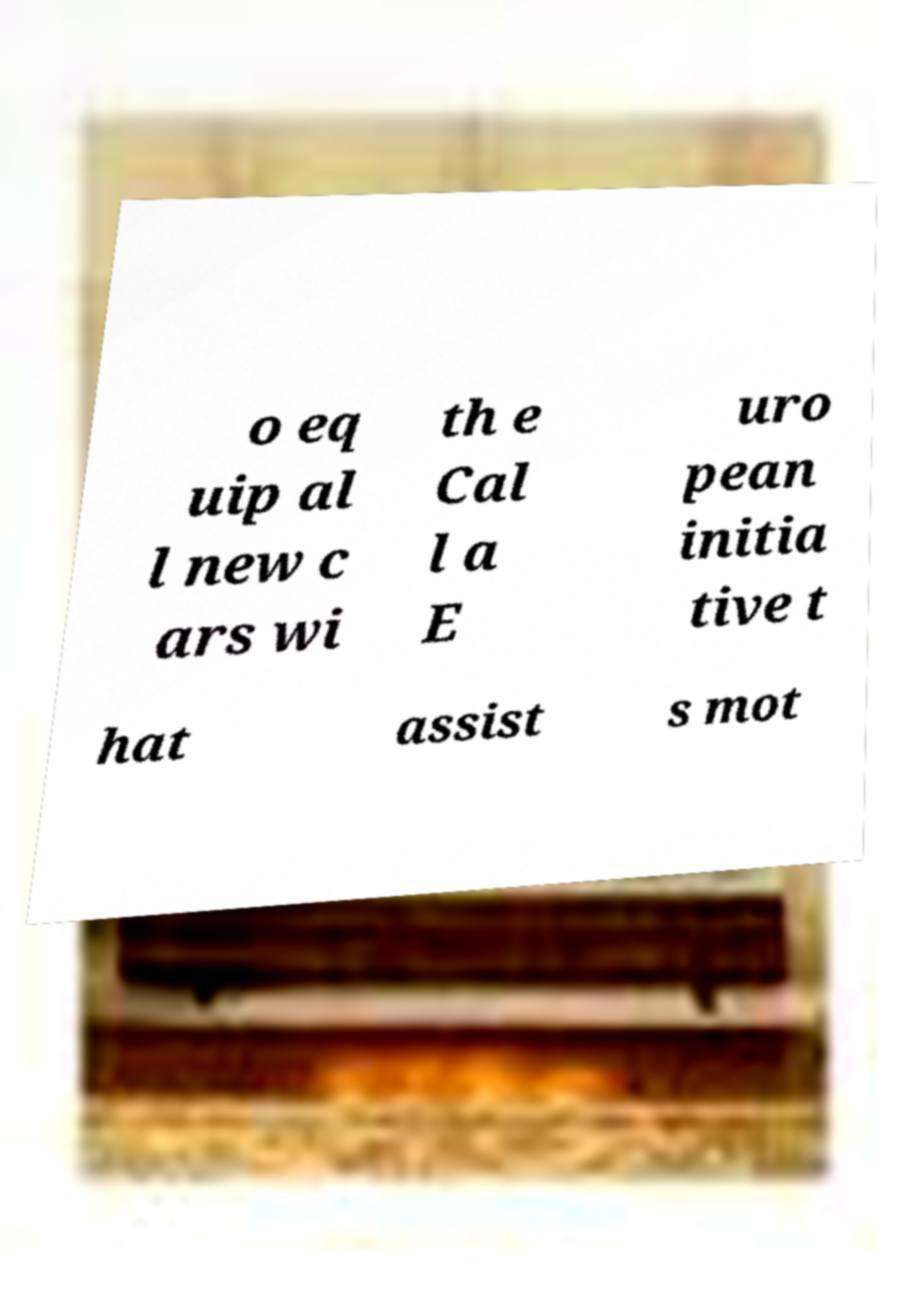What messages or text are displayed in this image? I need them in a readable, typed format. o eq uip al l new c ars wi th e Cal l a E uro pean initia tive t hat assist s mot 